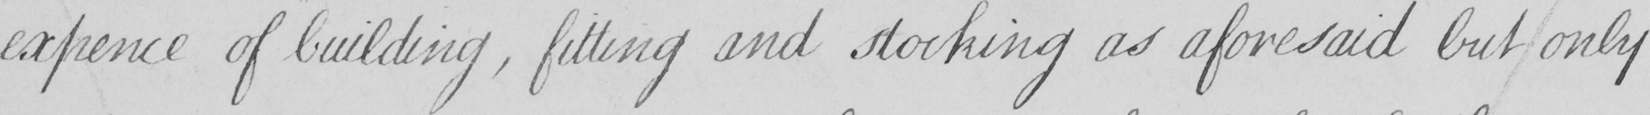Transcribe the text shown in this historical manuscript line. expence of building , fitting and stocking as aforesaid but only 